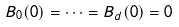<formula> <loc_0><loc_0><loc_500><loc_500>B _ { 0 } ( 0 ) = \dots = B _ { d } ( 0 ) = 0</formula> 